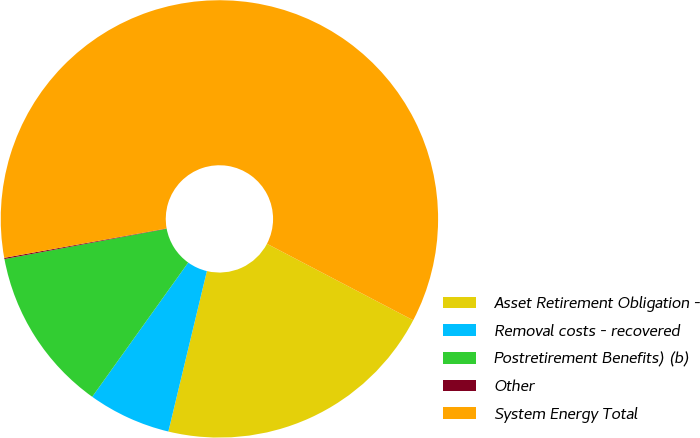<chart> <loc_0><loc_0><loc_500><loc_500><pie_chart><fcel>Asset Retirement Obligation -<fcel>Removal costs - recovered<fcel>Postretirement Benefits) (b)<fcel>Other<fcel>System Energy Total<nl><fcel>21.08%<fcel>6.13%<fcel>12.18%<fcel>0.09%<fcel>60.52%<nl></chart> 